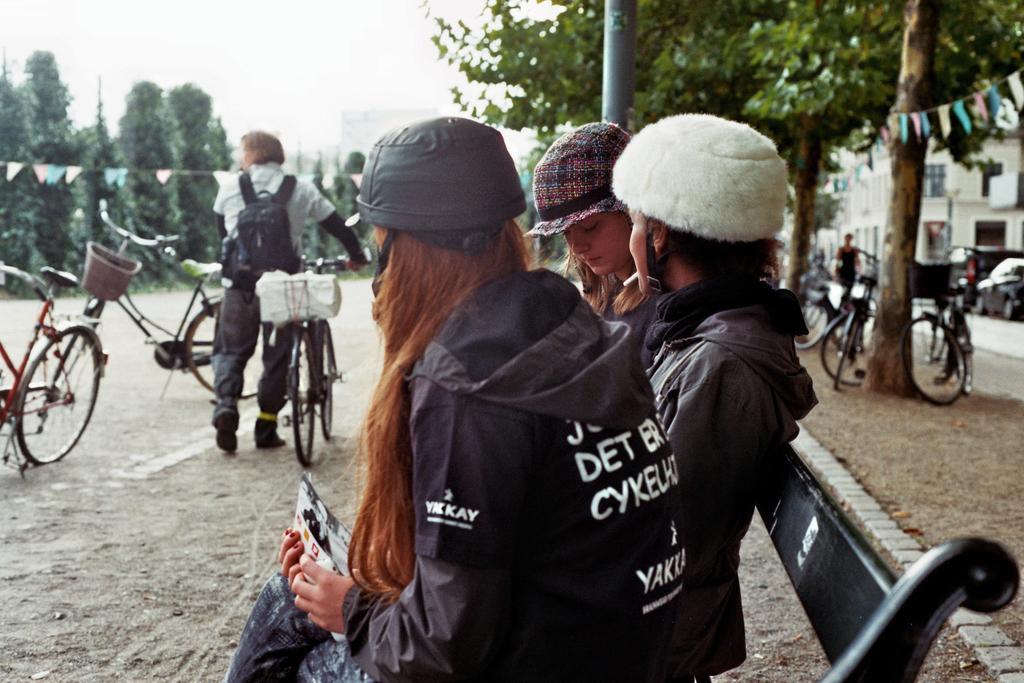Can you describe this image briefly? There are people sitting on a bench in the foreground area of the image, there is a person with a bicycle, trees, people, vehicles, bicycles, buildings, pole and sky in the background area. 